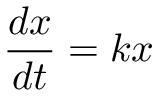<formula> <loc_0><loc_0><loc_500><loc_500>\, { \frac { d x } { d t } } = k x</formula> 